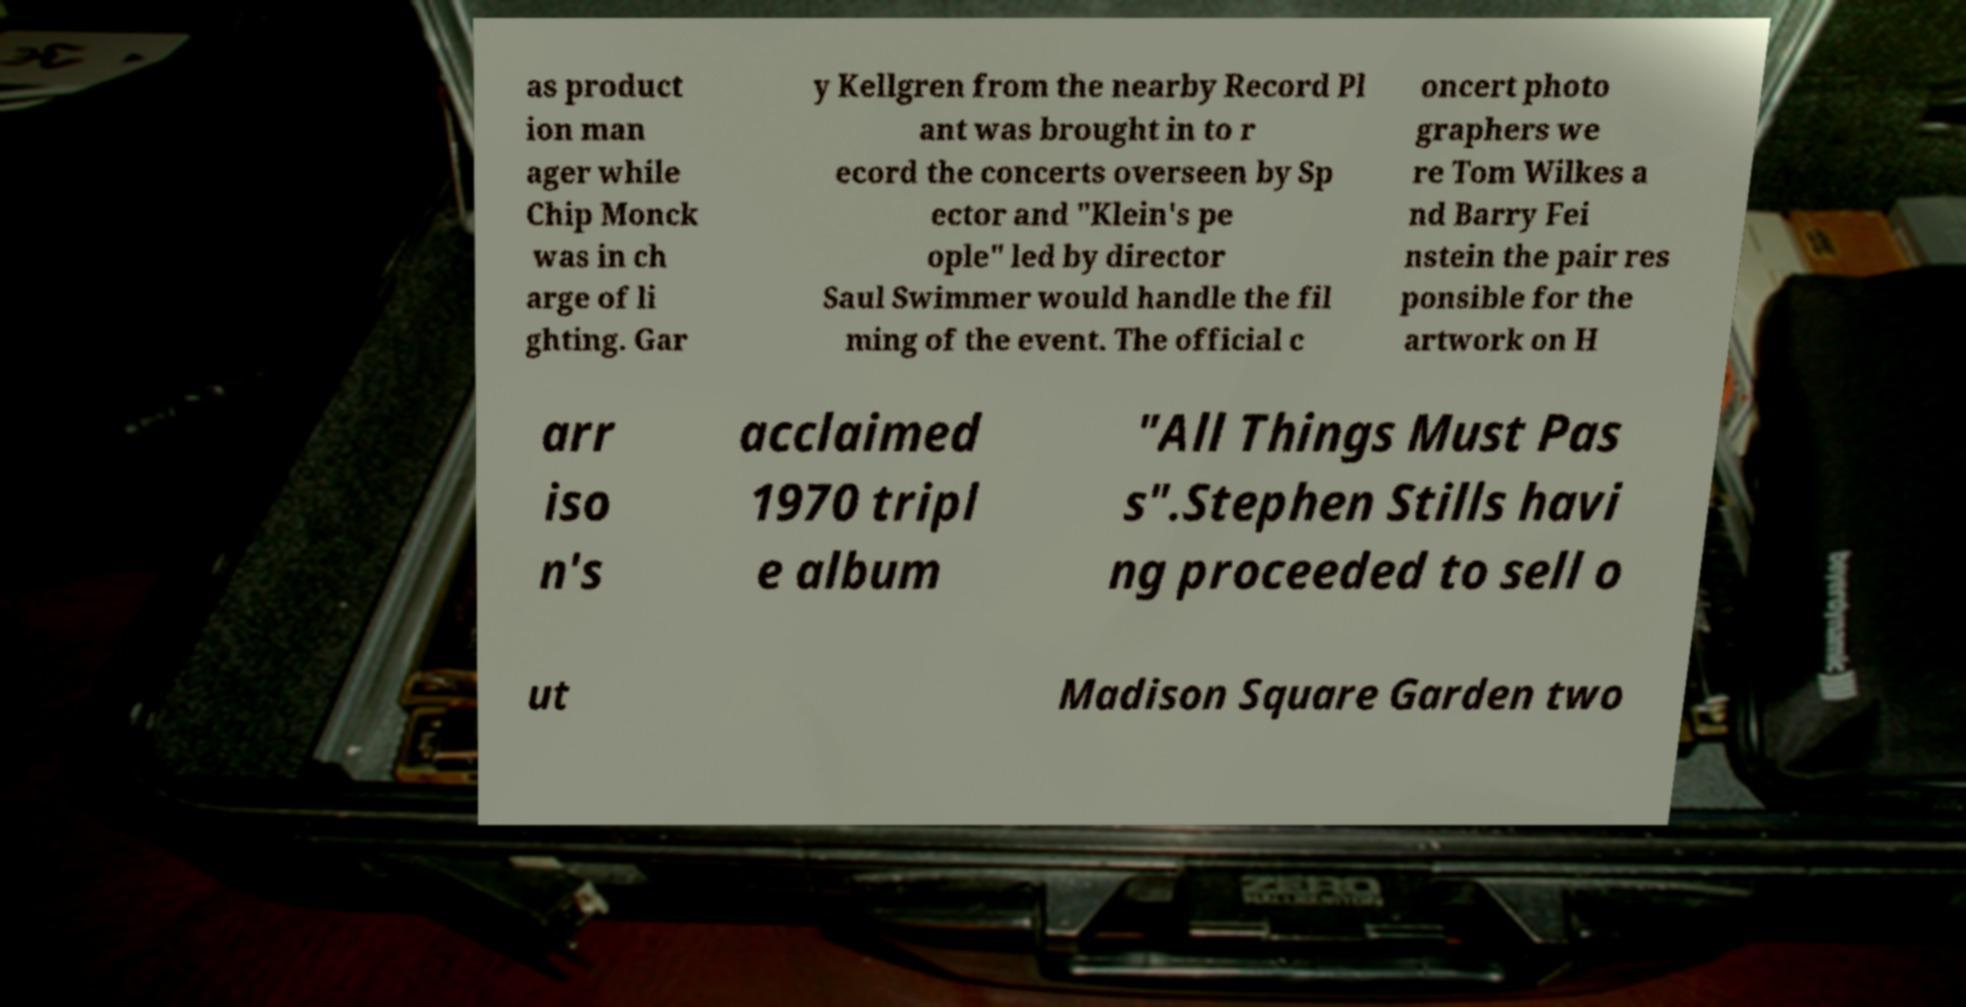Please identify and transcribe the text found in this image. as product ion man ager while Chip Monck was in ch arge of li ghting. Gar y Kellgren from the nearby Record Pl ant was brought in to r ecord the concerts overseen by Sp ector and "Klein's pe ople" led by director Saul Swimmer would handle the fil ming of the event. The official c oncert photo graphers we re Tom Wilkes a nd Barry Fei nstein the pair res ponsible for the artwork on H arr iso n's acclaimed 1970 tripl e album "All Things Must Pas s".Stephen Stills havi ng proceeded to sell o ut Madison Square Garden two 